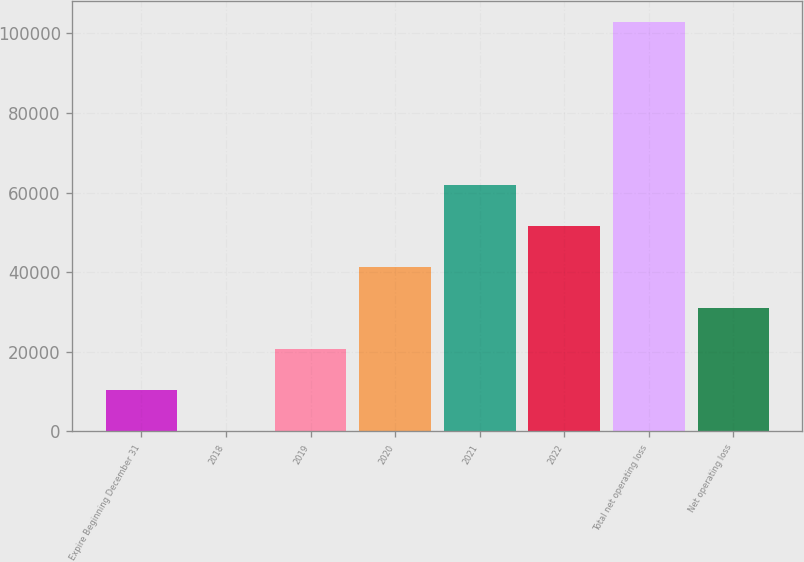<chart> <loc_0><loc_0><loc_500><loc_500><bar_chart><fcel>Expire Beginning December 31<fcel>2018<fcel>2019<fcel>2020<fcel>2021<fcel>2022<fcel>Total net operating loss<fcel>Net operating loss<nl><fcel>10464<fcel>189<fcel>20739<fcel>41289<fcel>61839<fcel>51564<fcel>102939<fcel>31014<nl></chart> 